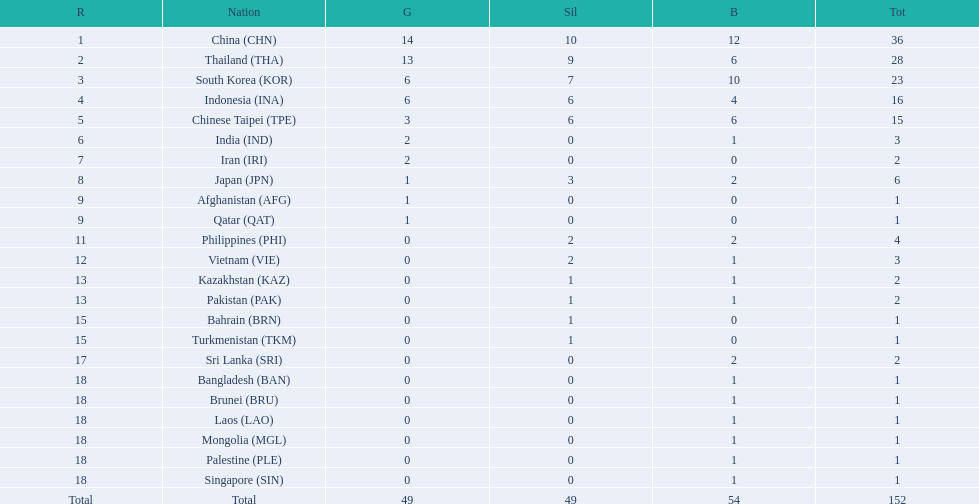What is the count of nations that obtained a medal in gold, silver, and bronze categories each? 6. Parse the full table. {'header': ['R', 'Nation', 'G', 'Sil', 'B', 'Tot'], 'rows': [['1', 'China\xa0(CHN)', '14', '10', '12', '36'], ['2', 'Thailand\xa0(THA)', '13', '9', '6', '28'], ['3', 'South Korea\xa0(KOR)', '6', '7', '10', '23'], ['4', 'Indonesia\xa0(INA)', '6', '6', '4', '16'], ['5', 'Chinese Taipei\xa0(TPE)', '3', '6', '6', '15'], ['6', 'India\xa0(IND)', '2', '0', '1', '3'], ['7', 'Iran\xa0(IRI)', '2', '0', '0', '2'], ['8', 'Japan\xa0(JPN)', '1', '3', '2', '6'], ['9', 'Afghanistan\xa0(AFG)', '1', '0', '0', '1'], ['9', 'Qatar\xa0(QAT)', '1', '0', '0', '1'], ['11', 'Philippines\xa0(PHI)', '0', '2', '2', '4'], ['12', 'Vietnam\xa0(VIE)', '0', '2', '1', '3'], ['13', 'Kazakhstan\xa0(KAZ)', '0', '1', '1', '2'], ['13', 'Pakistan\xa0(PAK)', '0', '1', '1', '2'], ['15', 'Bahrain\xa0(BRN)', '0', '1', '0', '1'], ['15', 'Turkmenistan\xa0(TKM)', '0', '1', '0', '1'], ['17', 'Sri Lanka\xa0(SRI)', '0', '0', '2', '2'], ['18', 'Bangladesh\xa0(BAN)', '0', '0', '1', '1'], ['18', 'Brunei\xa0(BRU)', '0', '0', '1', '1'], ['18', 'Laos\xa0(LAO)', '0', '0', '1', '1'], ['18', 'Mongolia\xa0(MGL)', '0', '0', '1', '1'], ['18', 'Palestine\xa0(PLE)', '0', '0', '1', '1'], ['18', 'Singapore\xa0(SIN)', '0', '0', '1', '1'], ['Total', 'Total', '49', '49', '54', '152']]} 